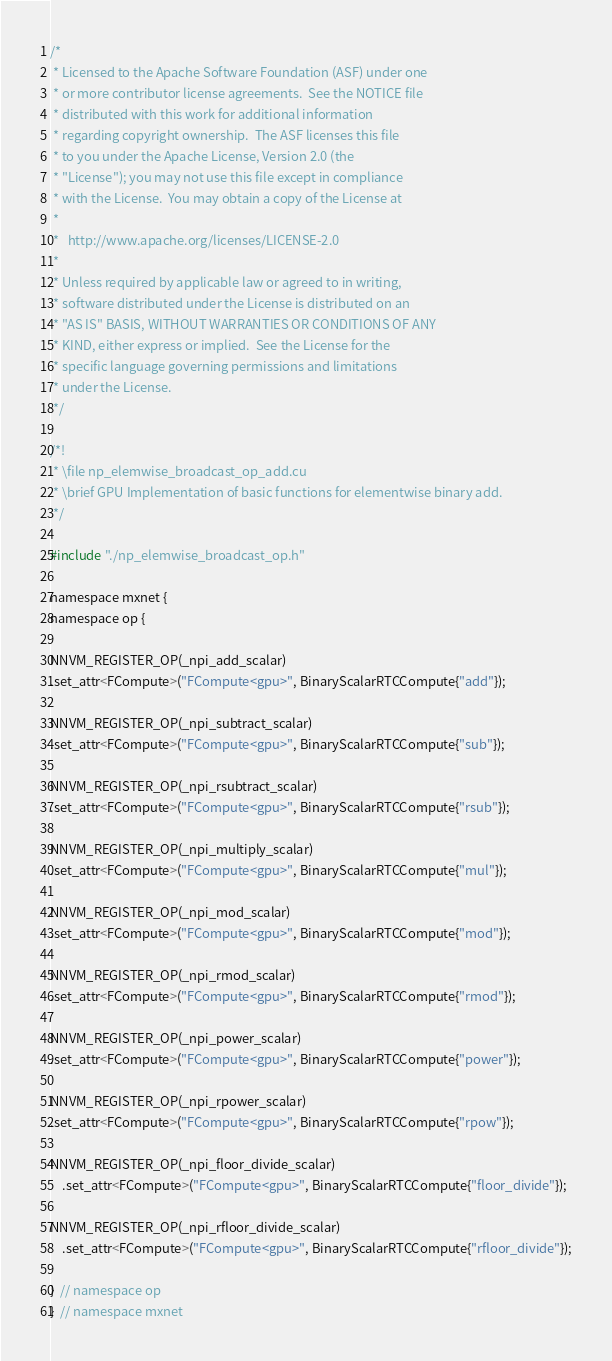<code> <loc_0><loc_0><loc_500><loc_500><_Cuda_>/*
 * Licensed to the Apache Software Foundation (ASF) under one
 * or more contributor license agreements.  See the NOTICE file
 * distributed with this work for additional information
 * regarding copyright ownership.  The ASF licenses this file
 * to you under the Apache License, Version 2.0 (the
 * "License"); you may not use this file except in compliance
 * with the License.  You may obtain a copy of the License at
 *
 *   http://www.apache.org/licenses/LICENSE-2.0
 *
 * Unless required by applicable law or agreed to in writing,
 * software distributed under the License is distributed on an
 * "AS IS" BASIS, WITHOUT WARRANTIES OR CONDITIONS OF ANY
 * KIND, either express or implied.  See the License for the
 * specific language governing permissions and limitations
 * under the License.
 */

/*!
 * \file np_elemwise_broadcast_op_add.cu
 * \brief GPU Implementation of basic functions for elementwise binary add.
 */

#include "./np_elemwise_broadcast_op.h"

namespace mxnet {
namespace op {

NNVM_REGISTER_OP(_npi_add_scalar)
.set_attr<FCompute>("FCompute<gpu>", BinaryScalarRTCCompute{"add"});

NNVM_REGISTER_OP(_npi_subtract_scalar)
.set_attr<FCompute>("FCompute<gpu>", BinaryScalarRTCCompute{"sub"});

NNVM_REGISTER_OP(_npi_rsubtract_scalar)
.set_attr<FCompute>("FCompute<gpu>", BinaryScalarRTCCompute{"rsub"});

NNVM_REGISTER_OP(_npi_multiply_scalar)
.set_attr<FCompute>("FCompute<gpu>", BinaryScalarRTCCompute{"mul"});

NNVM_REGISTER_OP(_npi_mod_scalar)
.set_attr<FCompute>("FCompute<gpu>", BinaryScalarRTCCompute{"mod"});

NNVM_REGISTER_OP(_npi_rmod_scalar)
.set_attr<FCompute>("FCompute<gpu>", BinaryScalarRTCCompute{"rmod"});

NNVM_REGISTER_OP(_npi_power_scalar)
.set_attr<FCompute>("FCompute<gpu>", BinaryScalarRTCCompute{"power"});

NNVM_REGISTER_OP(_npi_rpower_scalar)
.set_attr<FCompute>("FCompute<gpu>", BinaryScalarRTCCompute{"rpow"});

NNVM_REGISTER_OP(_npi_floor_divide_scalar)
    .set_attr<FCompute>("FCompute<gpu>", BinaryScalarRTCCompute{"floor_divide"});

NNVM_REGISTER_OP(_npi_rfloor_divide_scalar)
    .set_attr<FCompute>("FCompute<gpu>", BinaryScalarRTCCompute{"rfloor_divide"});

}  // namespace op
}  // namespace mxnet
</code> 